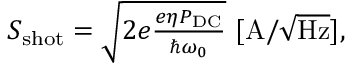Convert formula to latex. <formula><loc_0><loc_0><loc_500><loc_500>\begin{array} { r } { S _ { s h o t } = \sqrt { 2 e \frac { e \eta P _ { D C } } { \hbar { \omega } _ { 0 } } } \ [ A / \sqrt { H z } ] , } \end{array}</formula> 